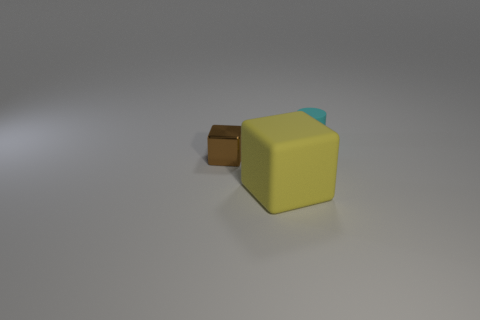Are the cube that is behind the big rubber thing and the small thing behind the tiny brown cube made of the same material?
Ensure brevity in your answer.  No. There is a object in front of the block that is left of the large yellow rubber thing; what size is it?
Give a very brief answer. Large. Are there any things that have the same color as the tiny shiny block?
Provide a succinct answer. No. Is the color of the block that is behind the yellow thing the same as the object that is in front of the tiny metal block?
Your answer should be very brief. No. What is the shape of the cyan thing?
Provide a short and direct response. Cylinder. There is a cyan cylinder; what number of matte cylinders are right of it?
Provide a succinct answer. 0. What number of other large yellow things have the same material as the big yellow object?
Your answer should be compact. 0. Is the cube right of the tiny shiny thing made of the same material as the tiny brown object?
Your answer should be very brief. No. Are any tiny brown things visible?
Give a very brief answer. Yes. There is a object that is both on the right side of the tiny brown metallic thing and behind the big cube; what is its size?
Your answer should be compact. Small. 